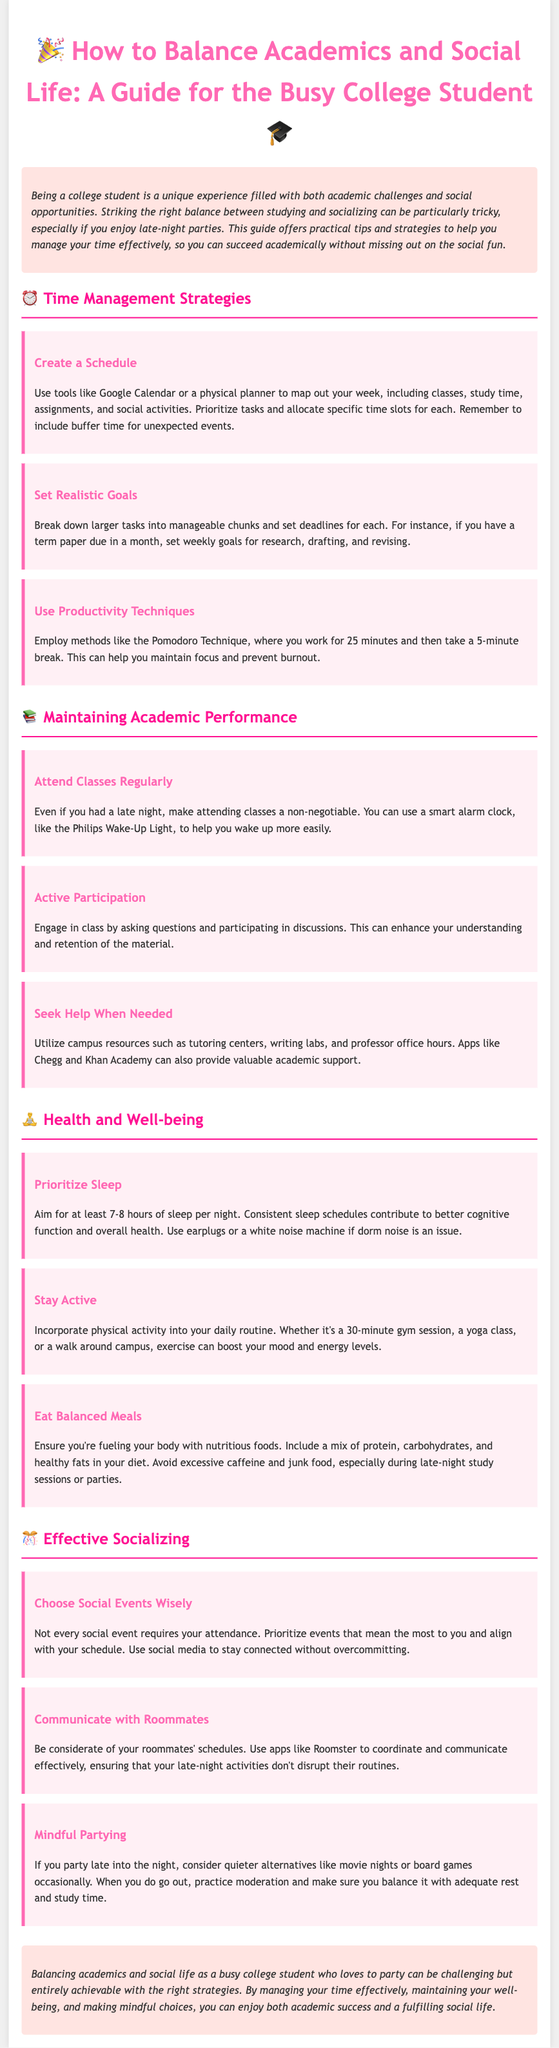What is a suggested tool for scheduling? The document suggests using tools like Google Calendar or a physical planner for scheduling.
Answer: Google Calendar How many hours of sleep should you aim for? The document states that you should aim for at least 7-8 hours of sleep per night.
Answer: 7-8 hours What technique can help maintain focus while studying? The Pomodoro Technique, which involves working for 25 minutes and then taking a 5-minute break, can help maintain focus.
Answer: Pomodoro Technique What should you prioritize when choosing social events? The document advises prioritizing events that mean the most to you and align with your schedule.
Answer: Events that mean the most What is a suggested app for communicating with roommates? The document mentions using the app Roomster to coordinate and communicate with roommates.
Answer: Roomster Why is attending classes important, even after a late night? Attending classes is essential as it is framed as a non-negotiable part of academic life in the document.
Answer: Non-negotiable What is one way to incorporate physical activity into your routine? The document suggests activities like a 30-minute gym session, yoga class, or a walk around campus as ways to stay active.
Answer: 30-minute gym session How can you enhance understanding and retention of material in class? Engaging in class by asking questions and participating in discussions can enhance understanding and retention.
Answer: Asking questions What type of events should you consider when partying late into the night? The document recommends considering quieter alternatives like movie nights or board games occasionally when partying late.
Answer: Quieter alternatives 